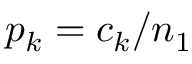Convert formula to latex. <formula><loc_0><loc_0><loc_500><loc_500>p _ { k } = c _ { k } / n _ { 1 }</formula> 